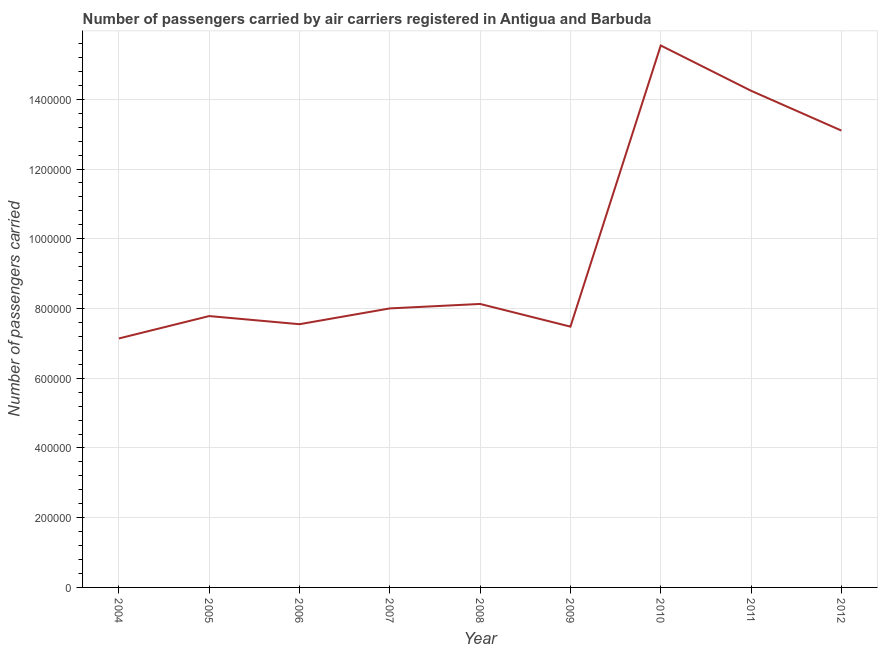What is the number of passengers carried in 2005?
Provide a succinct answer. 7.78e+05. Across all years, what is the maximum number of passengers carried?
Your answer should be very brief. 1.55e+06. Across all years, what is the minimum number of passengers carried?
Offer a very short reply. 7.14e+05. What is the sum of the number of passengers carried?
Your answer should be very brief. 8.90e+06. What is the difference between the number of passengers carried in 2006 and 2011?
Provide a succinct answer. -6.70e+05. What is the average number of passengers carried per year?
Give a very brief answer. 9.89e+05. What is the median number of passengers carried?
Make the answer very short. 8.00e+05. Do a majority of the years between 2004 and 2012 (inclusive) have number of passengers carried greater than 440000 ?
Give a very brief answer. Yes. What is the ratio of the number of passengers carried in 2005 to that in 2010?
Give a very brief answer. 0.5. Is the number of passengers carried in 2004 less than that in 2007?
Make the answer very short. Yes. What is the difference between the highest and the second highest number of passengers carried?
Provide a succinct answer. 1.30e+05. Is the sum of the number of passengers carried in 2007 and 2008 greater than the maximum number of passengers carried across all years?
Provide a short and direct response. Yes. What is the difference between the highest and the lowest number of passengers carried?
Provide a short and direct response. 8.40e+05. In how many years, is the number of passengers carried greater than the average number of passengers carried taken over all years?
Give a very brief answer. 3. Does the number of passengers carried monotonically increase over the years?
Keep it short and to the point. No. How many lines are there?
Give a very brief answer. 1. How many years are there in the graph?
Provide a succinct answer. 9. Are the values on the major ticks of Y-axis written in scientific E-notation?
Keep it short and to the point. No. Does the graph contain grids?
Provide a succinct answer. Yes. What is the title of the graph?
Offer a very short reply. Number of passengers carried by air carriers registered in Antigua and Barbuda. What is the label or title of the Y-axis?
Offer a terse response. Number of passengers carried. What is the Number of passengers carried in 2004?
Make the answer very short. 7.14e+05. What is the Number of passengers carried in 2005?
Your answer should be very brief. 7.78e+05. What is the Number of passengers carried in 2006?
Keep it short and to the point. 7.55e+05. What is the Number of passengers carried in 2007?
Your response must be concise. 8.00e+05. What is the Number of passengers carried of 2008?
Keep it short and to the point. 8.13e+05. What is the Number of passengers carried in 2009?
Your answer should be very brief. 7.48e+05. What is the Number of passengers carried of 2010?
Provide a short and direct response. 1.55e+06. What is the Number of passengers carried of 2011?
Your response must be concise. 1.42e+06. What is the Number of passengers carried in 2012?
Offer a very short reply. 1.31e+06. What is the difference between the Number of passengers carried in 2004 and 2005?
Provide a short and direct response. -6.43e+04. What is the difference between the Number of passengers carried in 2004 and 2006?
Provide a succinct answer. -4.09e+04. What is the difference between the Number of passengers carried in 2004 and 2007?
Provide a succinct answer. -8.62e+04. What is the difference between the Number of passengers carried in 2004 and 2008?
Provide a succinct answer. -9.90e+04. What is the difference between the Number of passengers carried in 2004 and 2009?
Keep it short and to the point. -3.40e+04. What is the difference between the Number of passengers carried in 2004 and 2010?
Give a very brief answer. -8.40e+05. What is the difference between the Number of passengers carried in 2004 and 2011?
Provide a succinct answer. -7.10e+05. What is the difference between the Number of passengers carried in 2004 and 2012?
Your answer should be very brief. -5.96e+05. What is the difference between the Number of passengers carried in 2005 and 2006?
Your answer should be very brief. 2.33e+04. What is the difference between the Number of passengers carried in 2005 and 2007?
Give a very brief answer. -2.19e+04. What is the difference between the Number of passengers carried in 2005 and 2008?
Give a very brief answer. -3.48e+04. What is the difference between the Number of passengers carried in 2005 and 2009?
Your response must be concise. 3.03e+04. What is the difference between the Number of passengers carried in 2005 and 2010?
Your answer should be compact. -7.76e+05. What is the difference between the Number of passengers carried in 2005 and 2011?
Offer a very short reply. -6.46e+05. What is the difference between the Number of passengers carried in 2005 and 2012?
Your answer should be compact. -5.32e+05. What is the difference between the Number of passengers carried in 2006 and 2007?
Keep it short and to the point. -4.53e+04. What is the difference between the Number of passengers carried in 2006 and 2008?
Provide a short and direct response. -5.81e+04. What is the difference between the Number of passengers carried in 2006 and 2009?
Your response must be concise. 6943. What is the difference between the Number of passengers carried in 2006 and 2010?
Your response must be concise. -7.99e+05. What is the difference between the Number of passengers carried in 2006 and 2011?
Your response must be concise. -6.70e+05. What is the difference between the Number of passengers carried in 2006 and 2012?
Your answer should be very brief. -5.55e+05. What is the difference between the Number of passengers carried in 2007 and 2008?
Your response must be concise. -1.28e+04. What is the difference between the Number of passengers carried in 2007 and 2009?
Keep it short and to the point. 5.22e+04. What is the difference between the Number of passengers carried in 2007 and 2010?
Ensure brevity in your answer.  -7.54e+05. What is the difference between the Number of passengers carried in 2007 and 2011?
Give a very brief answer. -6.24e+05. What is the difference between the Number of passengers carried in 2007 and 2012?
Offer a very short reply. -5.10e+05. What is the difference between the Number of passengers carried in 2008 and 2009?
Make the answer very short. 6.50e+04. What is the difference between the Number of passengers carried in 2008 and 2010?
Your response must be concise. -7.41e+05. What is the difference between the Number of passengers carried in 2008 and 2011?
Your response must be concise. -6.11e+05. What is the difference between the Number of passengers carried in 2008 and 2012?
Ensure brevity in your answer.  -4.97e+05. What is the difference between the Number of passengers carried in 2009 and 2010?
Provide a short and direct response. -8.06e+05. What is the difference between the Number of passengers carried in 2009 and 2011?
Ensure brevity in your answer.  -6.76e+05. What is the difference between the Number of passengers carried in 2009 and 2012?
Offer a terse response. -5.62e+05. What is the difference between the Number of passengers carried in 2010 and 2011?
Offer a very short reply. 1.30e+05. What is the difference between the Number of passengers carried in 2010 and 2012?
Provide a short and direct response. 2.44e+05. What is the difference between the Number of passengers carried in 2011 and 2012?
Your answer should be very brief. 1.14e+05. What is the ratio of the Number of passengers carried in 2004 to that in 2005?
Offer a terse response. 0.92. What is the ratio of the Number of passengers carried in 2004 to that in 2006?
Your answer should be compact. 0.95. What is the ratio of the Number of passengers carried in 2004 to that in 2007?
Offer a very short reply. 0.89. What is the ratio of the Number of passengers carried in 2004 to that in 2008?
Your answer should be very brief. 0.88. What is the ratio of the Number of passengers carried in 2004 to that in 2009?
Offer a very short reply. 0.95. What is the ratio of the Number of passengers carried in 2004 to that in 2010?
Your response must be concise. 0.46. What is the ratio of the Number of passengers carried in 2004 to that in 2011?
Make the answer very short. 0.5. What is the ratio of the Number of passengers carried in 2004 to that in 2012?
Provide a succinct answer. 0.55. What is the ratio of the Number of passengers carried in 2005 to that in 2006?
Offer a terse response. 1.03. What is the ratio of the Number of passengers carried in 2005 to that in 2007?
Offer a terse response. 0.97. What is the ratio of the Number of passengers carried in 2005 to that in 2010?
Offer a very short reply. 0.5. What is the ratio of the Number of passengers carried in 2005 to that in 2011?
Provide a short and direct response. 0.55. What is the ratio of the Number of passengers carried in 2005 to that in 2012?
Offer a very short reply. 0.59. What is the ratio of the Number of passengers carried in 2006 to that in 2007?
Provide a succinct answer. 0.94. What is the ratio of the Number of passengers carried in 2006 to that in 2008?
Your answer should be very brief. 0.93. What is the ratio of the Number of passengers carried in 2006 to that in 2009?
Your response must be concise. 1.01. What is the ratio of the Number of passengers carried in 2006 to that in 2010?
Your answer should be compact. 0.49. What is the ratio of the Number of passengers carried in 2006 to that in 2011?
Provide a short and direct response. 0.53. What is the ratio of the Number of passengers carried in 2006 to that in 2012?
Offer a terse response. 0.58. What is the ratio of the Number of passengers carried in 2007 to that in 2008?
Provide a short and direct response. 0.98. What is the ratio of the Number of passengers carried in 2007 to that in 2009?
Offer a terse response. 1.07. What is the ratio of the Number of passengers carried in 2007 to that in 2010?
Your answer should be compact. 0.52. What is the ratio of the Number of passengers carried in 2007 to that in 2011?
Keep it short and to the point. 0.56. What is the ratio of the Number of passengers carried in 2007 to that in 2012?
Keep it short and to the point. 0.61. What is the ratio of the Number of passengers carried in 2008 to that in 2009?
Your response must be concise. 1.09. What is the ratio of the Number of passengers carried in 2008 to that in 2010?
Offer a terse response. 0.52. What is the ratio of the Number of passengers carried in 2008 to that in 2011?
Give a very brief answer. 0.57. What is the ratio of the Number of passengers carried in 2008 to that in 2012?
Provide a short and direct response. 0.62. What is the ratio of the Number of passengers carried in 2009 to that in 2010?
Give a very brief answer. 0.48. What is the ratio of the Number of passengers carried in 2009 to that in 2011?
Your answer should be compact. 0.53. What is the ratio of the Number of passengers carried in 2009 to that in 2012?
Your response must be concise. 0.57. What is the ratio of the Number of passengers carried in 2010 to that in 2011?
Provide a short and direct response. 1.09. What is the ratio of the Number of passengers carried in 2010 to that in 2012?
Give a very brief answer. 1.19. What is the ratio of the Number of passengers carried in 2011 to that in 2012?
Provide a succinct answer. 1.09. 